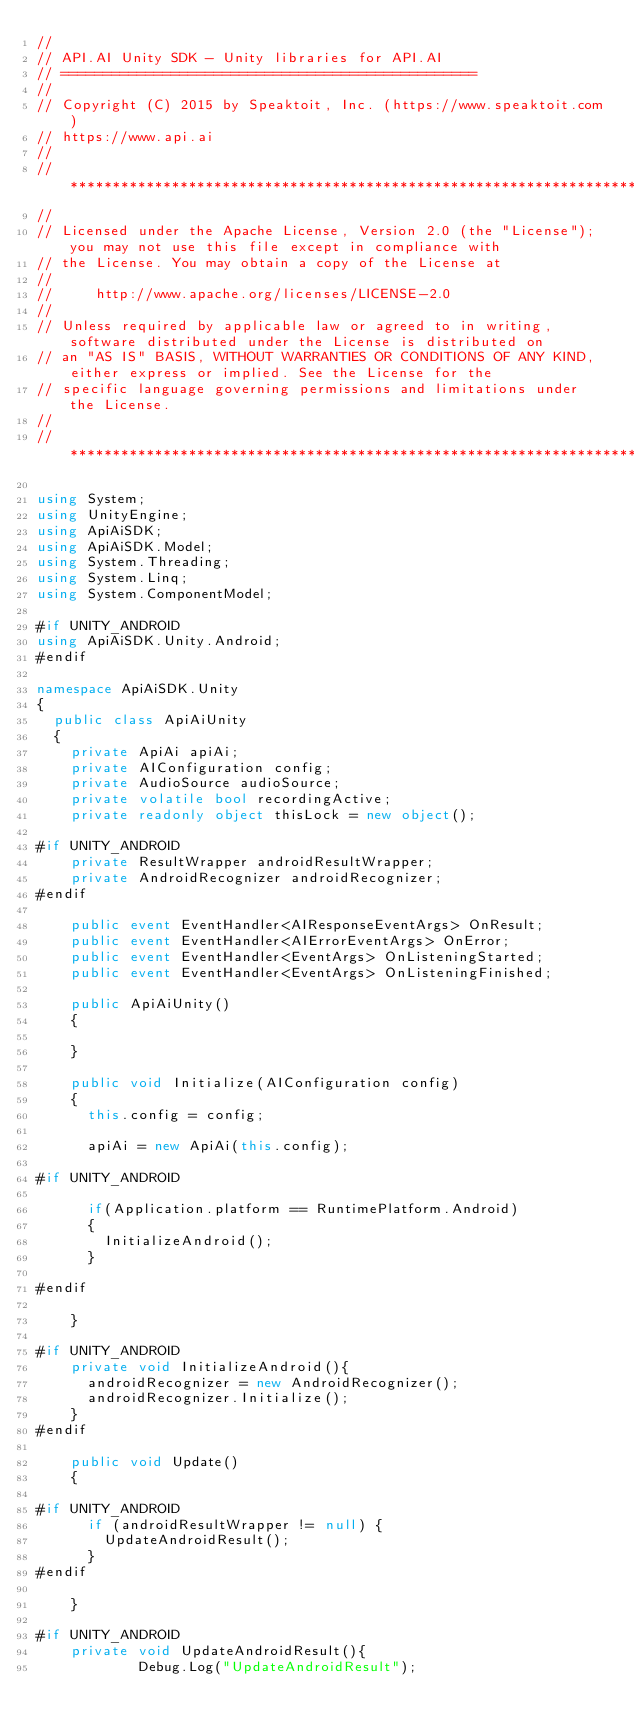<code> <loc_0><loc_0><loc_500><loc_500><_C#_>//
// API.AI Unity SDK - Unity libraries for API.AI
// =================================================
//
// Copyright (C) 2015 by Speaktoit, Inc. (https://www.speaktoit.com)
// https://www.api.ai
//
// ***********************************************************************************************************************
//
// Licensed under the Apache License, Version 2.0 (the "License"); you may not use this file except in compliance with
// the License. You may obtain a copy of the License at
//
//     http://www.apache.org/licenses/LICENSE-2.0
//
// Unless required by applicable law or agreed to in writing, software distributed under the License is distributed on
// an "AS IS" BASIS, WITHOUT WARRANTIES OR CONDITIONS OF ANY KIND, either express or implied. See the License for the
// specific language governing permissions and limitations under the License.
//
// ***********************************************************************************************************************

using System;
using UnityEngine;
using ApiAiSDK;
using ApiAiSDK.Model;
using System.Threading;
using System.Linq;
using System.ComponentModel;

#if UNITY_ANDROID
using ApiAiSDK.Unity.Android;
#endif

namespace ApiAiSDK.Unity
{	
	public class ApiAiUnity
	{
		private ApiAi apiAi;
		private AIConfiguration config;
		private AudioSource audioSource;
		private volatile bool recordingActive;
		private readonly object thisLock = new object();

#if UNITY_ANDROID
		private ResultWrapper androidResultWrapper;
		private AndroidRecognizer androidRecognizer;
#endif

		public event EventHandler<AIResponseEventArgs> OnResult;
		public event EventHandler<AIErrorEventArgs> OnError;
		public event EventHandler<EventArgs> OnListeningStarted;
		public event EventHandler<EventArgs> OnListeningFinished;

		public ApiAiUnity()
		{

		}

		public void Initialize(AIConfiguration config)
		{
			this.config = config;

			apiAi = new ApiAi(this.config);

#if UNITY_ANDROID

			if(Application.platform == RuntimePlatform.Android)
			{
				InitializeAndroid();
			}

#endif

		}
			
#if UNITY_ANDROID
		private void InitializeAndroid(){
			androidRecognizer = new AndroidRecognizer();
			androidRecognizer.Initialize();
		}
#endif

		public void Update()
		{

#if UNITY_ANDROID
			if (androidResultWrapper != null) {
				UpdateAndroidResult();
			}
#endif

		}

#if UNITY_ANDROID
		private void UpdateAndroidResult(){
            Debug.Log("UpdateAndroidResult");</code> 